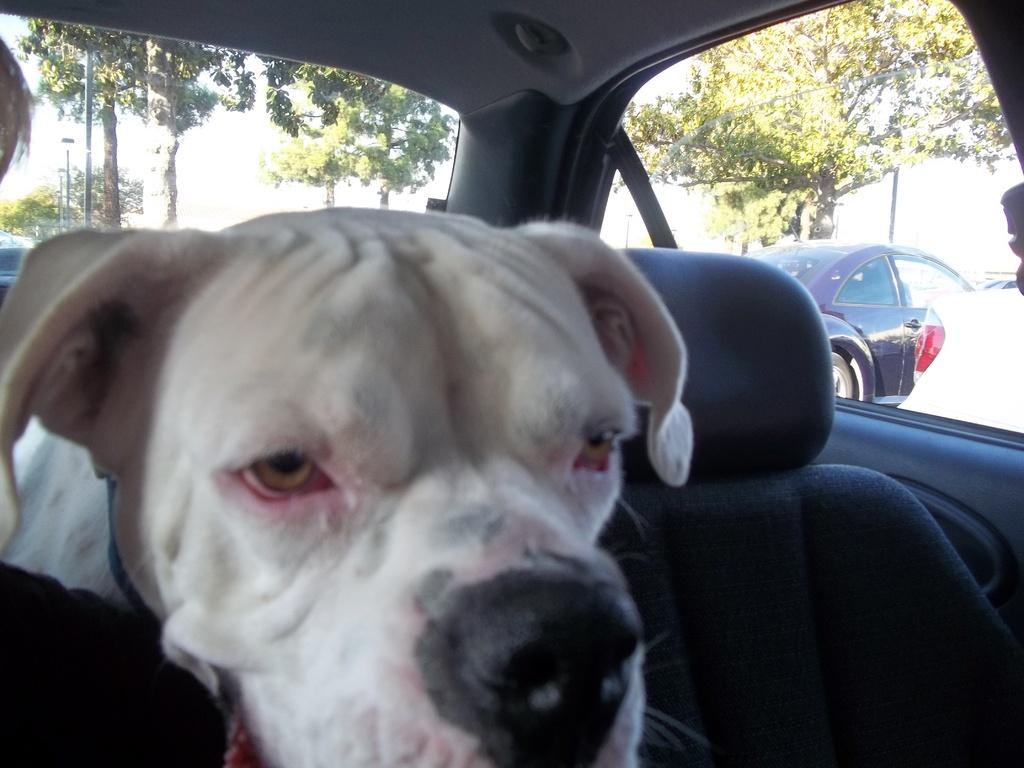What is the setting of the image? The image is an inside view of a car. What can be seen inside the car? There is a dog inside the car. What is visible outside the car? Trees and another car are visible outside the car. Where is the needle located in the image? There is no needle present in the image. What type of tramp is visible in the image? There is no tramp present in the image. 